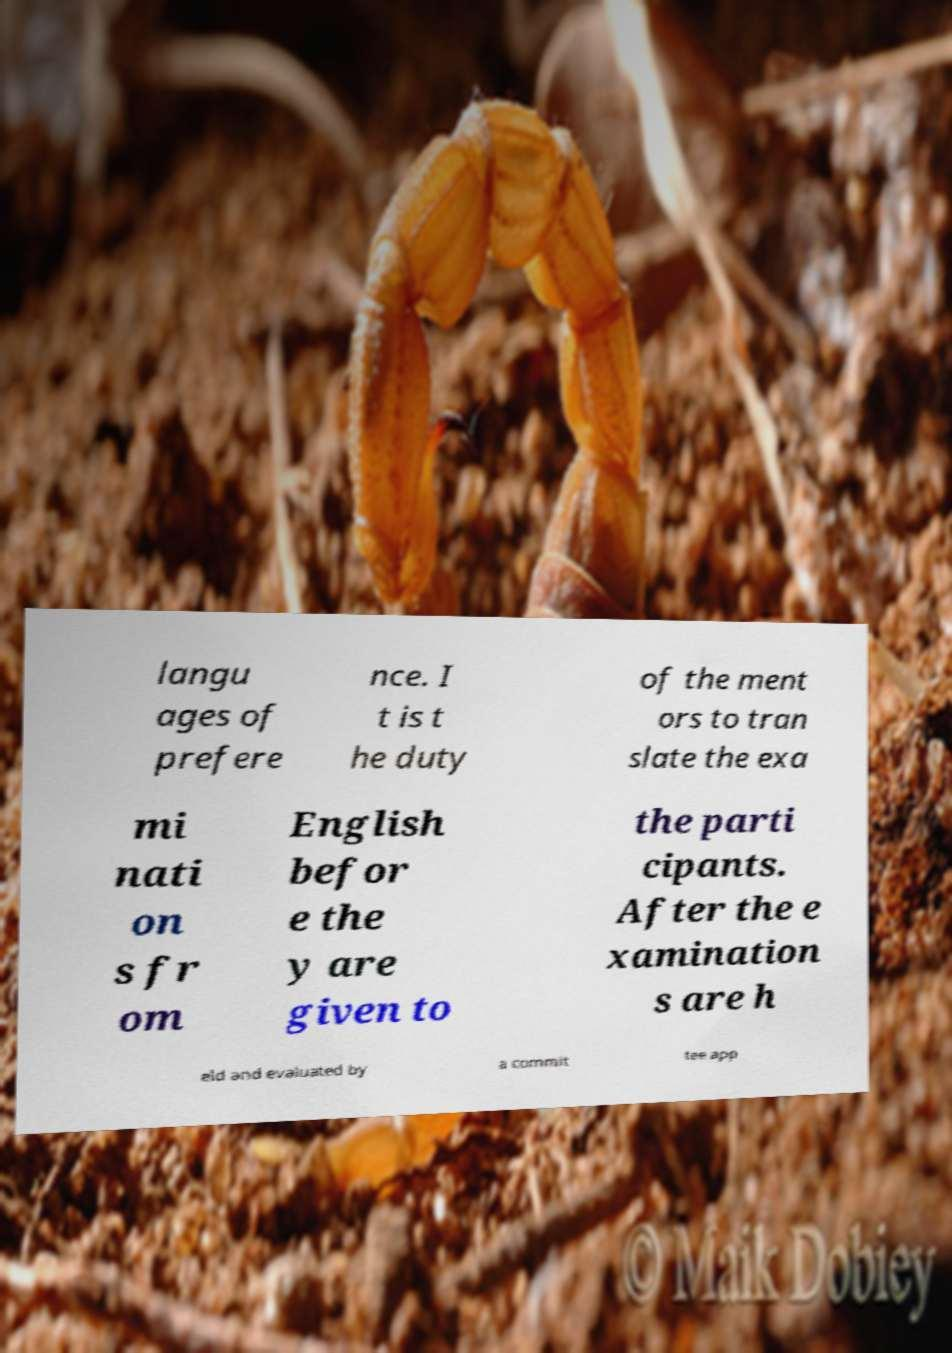Please identify and transcribe the text found in this image. langu ages of prefere nce. I t is t he duty of the ment ors to tran slate the exa mi nati on s fr om English befor e the y are given to the parti cipants. After the e xamination s are h eld and evaluated by a commit tee app 